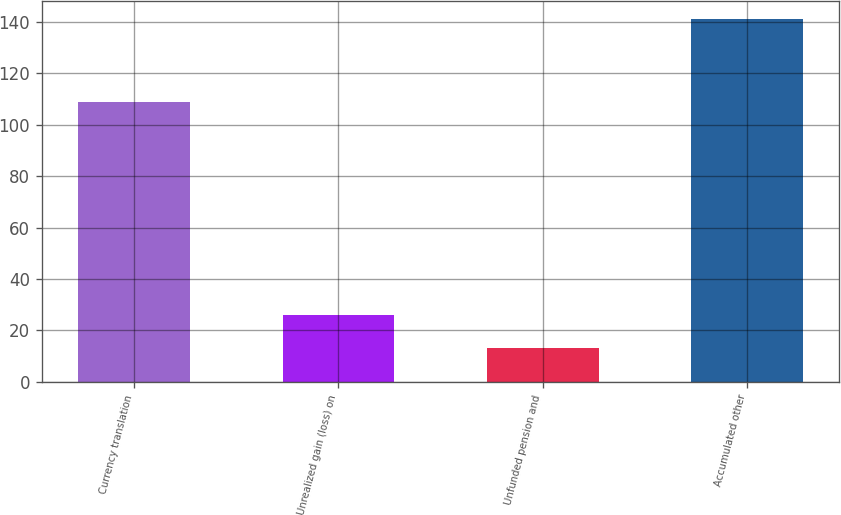<chart> <loc_0><loc_0><loc_500><loc_500><bar_chart><fcel>Currency translation<fcel>Unrealized gain (loss) on<fcel>Unfunded pension and<fcel>Accumulated other<nl><fcel>109<fcel>25.8<fcel>13<fcel>141<nl></chart> 